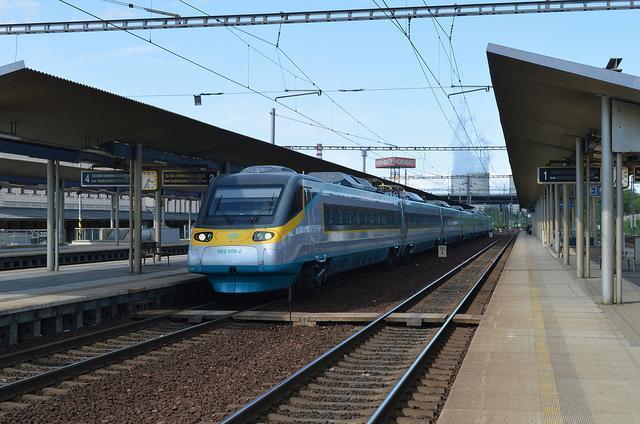How many sets of tracks are there?
Give a very brief answer. 2. How many tracks can be seen?
Give a very brief answer. 2. How many trains are there?
Give a very brief answer. 1. How many blue keyboards are there?
Give a very brief answer. 0. 